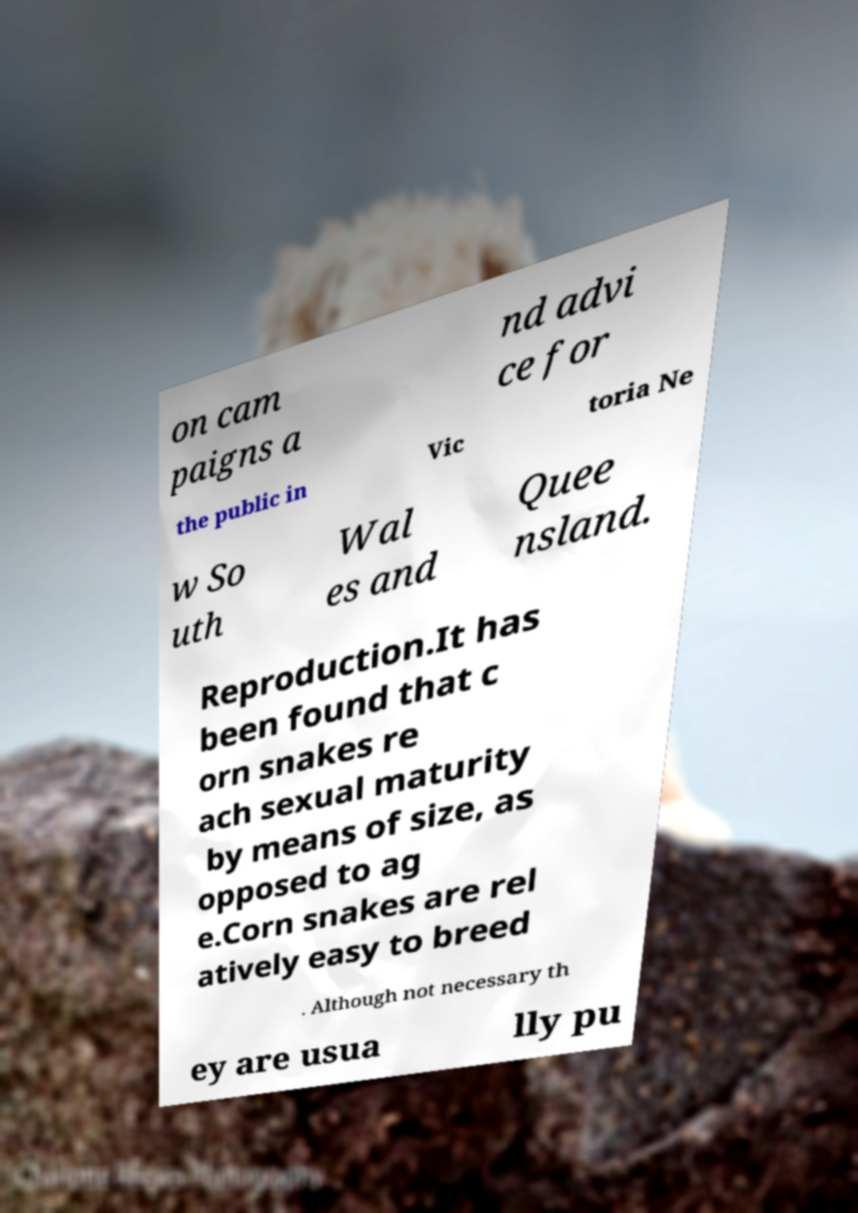Could you extract and type out the text from this image? on cam paigns a nd advi ce for the public in Vic toria Ne w So uth Wal es and Quee nsland. Reproduction.It has been found that c orn snakes re ach sexual maturity by means of size, as opposed to ag e.Corn snakes are rel atively easy to breed . Although not necessary th ey are usua lly pu 